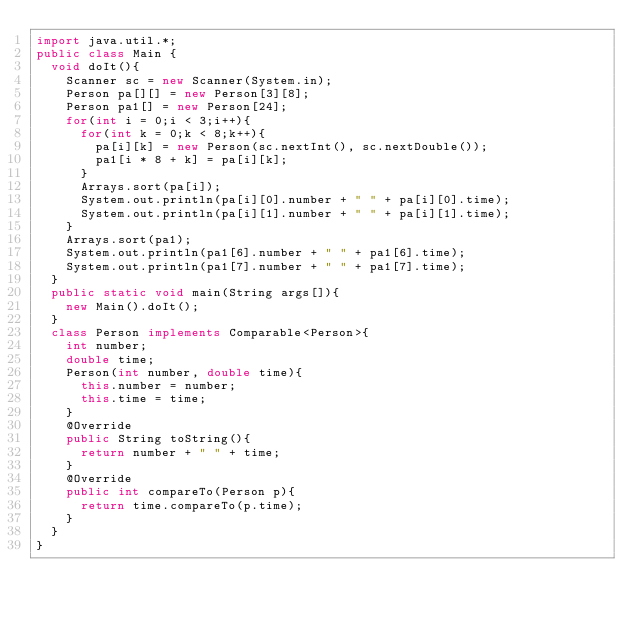<code> <loc_0><loc_0><loc_500><loc_500><_Java_>import java.util.*;
public class Main {
	void doIt(){
		Scanner sc = new Scanner(System.in);
		Person pa[][] = new Person[3][8];
		Person pa1[] = new Person[24];
		for(int i = 0;i < 3;i++){
			for(int k = 0;k < 8;k++){
				pa[i][k] = new Person(sc.nextInt(), sc.nextDouble());
				pa1[i * 8 + k] = pa[i][k];
			}
			Arrays.sort(pa[i]);
			System.out.println(pa[i][0].number + " " + pa[i][0].time);
			System.out.println(pa[i][1].number + " " + pa[i][1].time);
		}
		Arrays.sort(pa1);
		System.out.println(pa1[6].number + " " + pa1[6].time);
		System.out.println(pa1[7].number + " " + pa1[7].time);
	}
	public static void main(String args[]){
		new Main().doIt();
	}
	class Person implements Comparable<Person>{
		int number;
		double time;
		Person(int number, double time){
			this.number = number;
			this.time = time;
		}
		@Override
		public String toString(){
			return number + " " + time;
		}
		@Override
		public int compareTo(Person p){
			return time.compareTo(p.time);
		}
	}
}</code> 